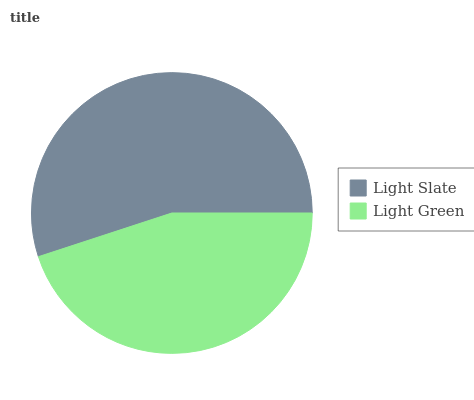Is Light Green the minimum?
Answer yes or no. Yes. Is Light Slate the maximum?
Answer yes or no. Yes. Is Light Green the maximum?
Answer yes or no. No. Is Light Slate greater than Light Green?
Answer yes or no. Yes. Is Light Green less than Light Slate?
Answer yes or no. Yes. Is Light Green greater than Light Slate?
Answer yes or no. No. Is Light Slate less than Light Green?
Answer yes or no. No. Is Light Slate the high median?
Answer yes or no. Yes. Is Light Green the low median?
Answer yes or no. Yes. Is Light Green the high median?
Answer yes or no. No. Is Light Slate the low median?
Answer yes or no. No. 